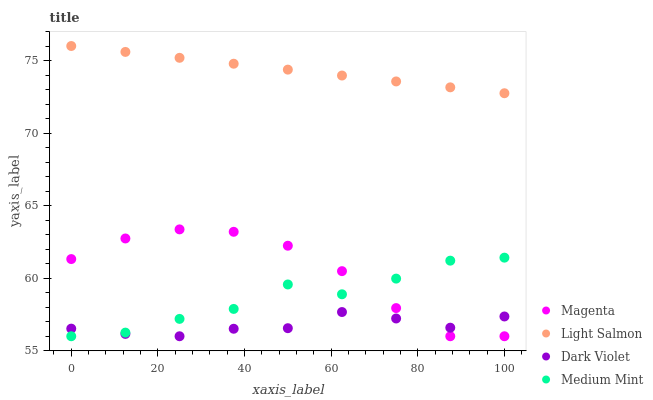Does Dark Violet have the minimum area under the curve?
Answer yes or no. Yes. Does Light Salmon have the maximum area under the curve?
Answer yes or no. Yes. Does Magenta have the minimum area under the curve?
Answer yes or no. No. Does Magenta have the maximum area under the curve?
Answer yes or no. No. Is Light Salmon the smoothest?
Answer yes or no. Yes. Is Medium Mint the roughest?
Answer yes or no. Yes. Is Magenta the smoothest?
Answer yes or no. No. Is Magenta the roughest?
Answer yes or no. No. Does Medium Mint have the lowest value?
Answer yes or no. Yes. Does Light Salmon have the lowest value?
Answer yes or no. No. Does Light Salmon have the highest value?
Answer yes or no. Yes. Does Magenta have the highest value?
Answer yes or no. No. Is Medium Mint less than Light Salmon?
Answer yes or no. Yes. Is Light Salmon greater than Dark Violet?
Answer yes or no. Yes. Does Dark Violet intersect Medium Mint?
Answer yes or no. Yes. Is Dark Violet less than Medium Mint?
Answer yes or no. No. Is Dark Violet greater than Medium Mint?
Answer yes or no. No. Does Medium Mint intersect Light Salmon?
Answer yes or no. No. 